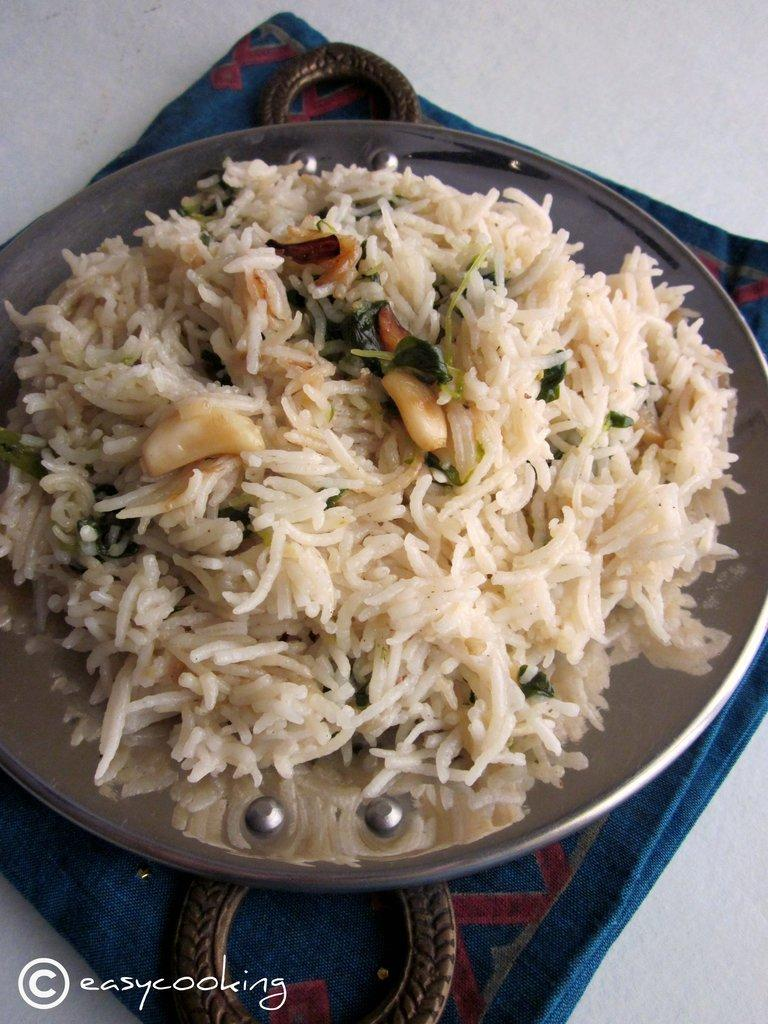What is on the floor in the image? There is a mat on the floor in the image. What is placed on the mat? There is a plate with food items on the mat. What type of wrench is being used to prepare the food on the plate? There is no wrench present in the image, and the food is already prepared on the plate. What is the purpose of the food on the plate in the image? The purpose of the food on the plate cannot be determined from the image alone, as it depends on the context and the person who placed it there. 